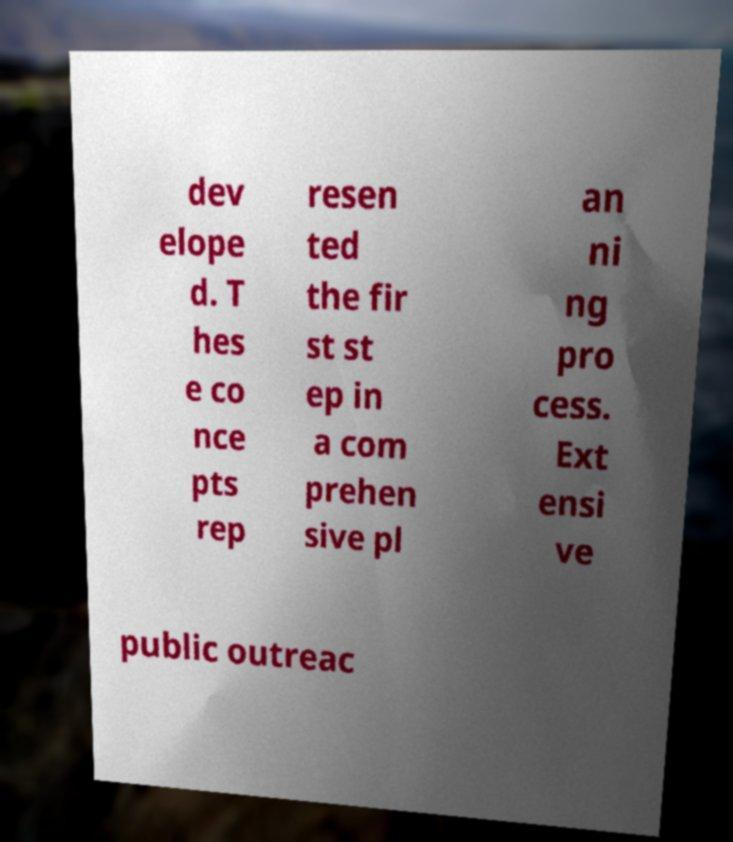Can you read and provide the text displayed in the image?This photo seems to have some interesting text. Can you extract and type it out for me? dev elope d. T hes e co nce pts rep resen ted the fir st st ep in a com prehen sive pl an ni ng pro cess. Ext ensi ve public outreac 